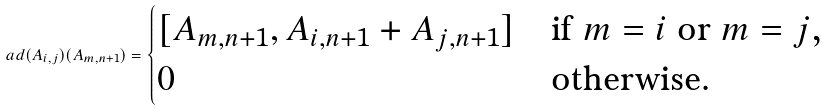<formula> <loc_0><loc_0><loc_500><loc_500>\ a d ( A _ { i , j } ) ( A _ { m , n + 1 } ) = \begin{cases} [ A _ { m , n + 1 } , A _ { i , n + 1 } + A _ { j , n + 1 } ] & \text {if $m=i$ or $m=j$,} \\ 0 & \text {otherwise.} \end{cases}</formula> 